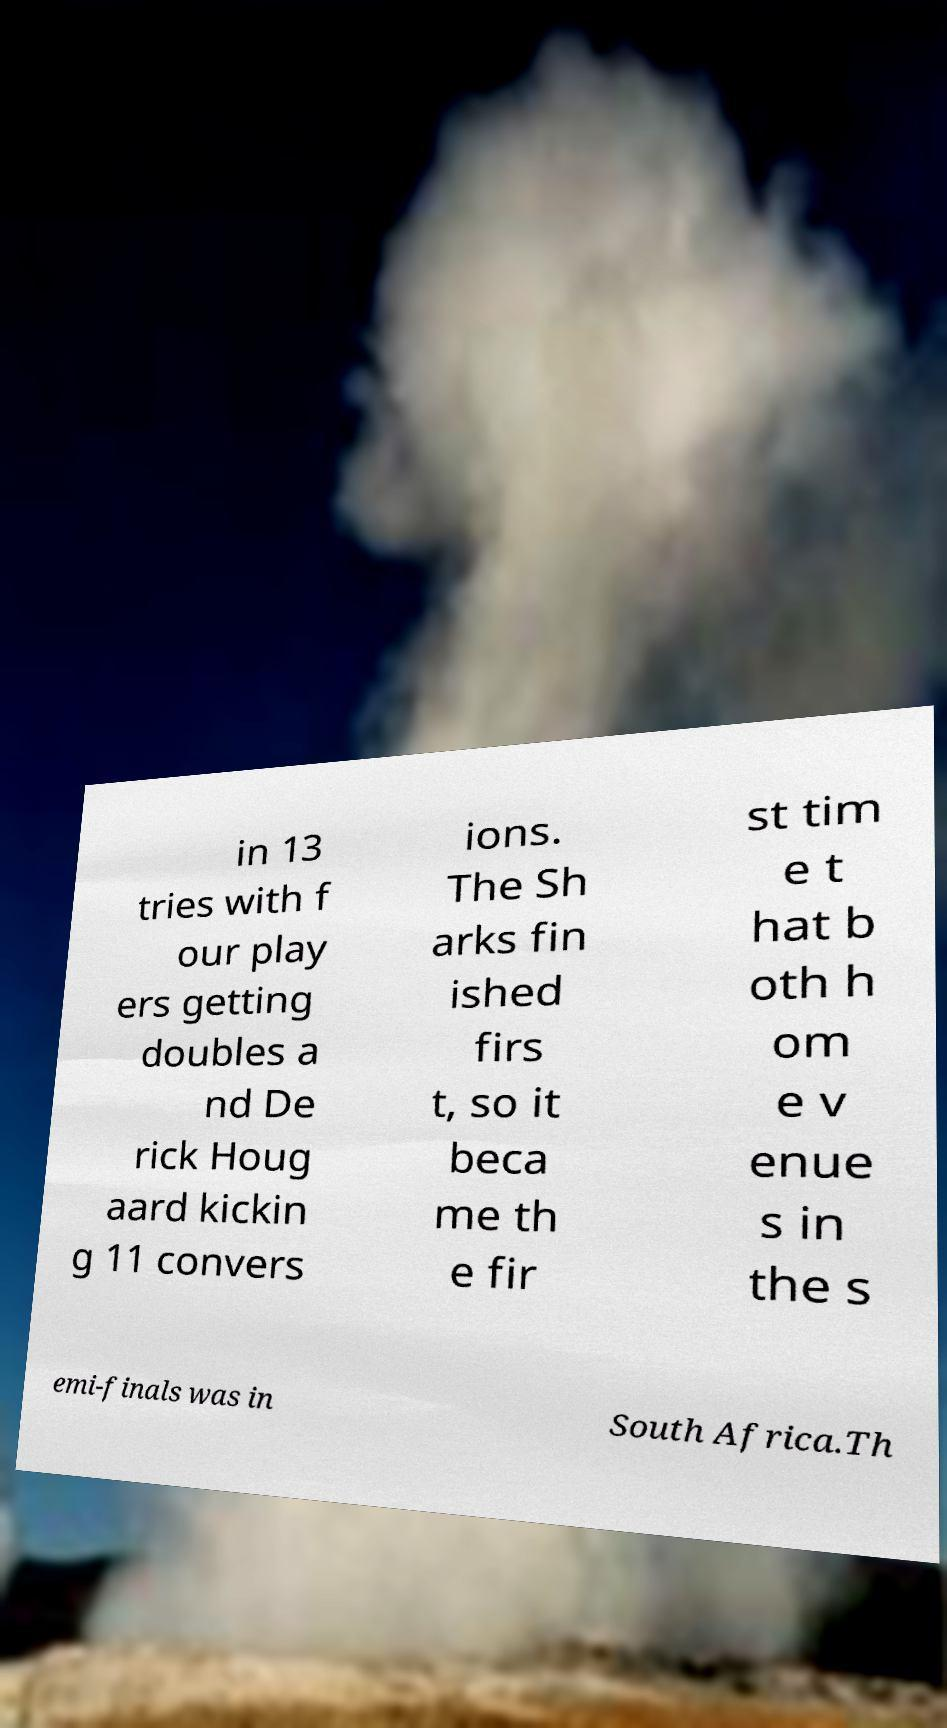Could you extract and type out the text from this image? in 13 tries with f our play ers getting doubles a nd De rick Houg aard kickin g 11 convers ions. The Sh arks fin ished firs t, so it beca me th e fir st tim e t hat b oth h om e v enue s in the s emi-finals was in South Africa.Th 